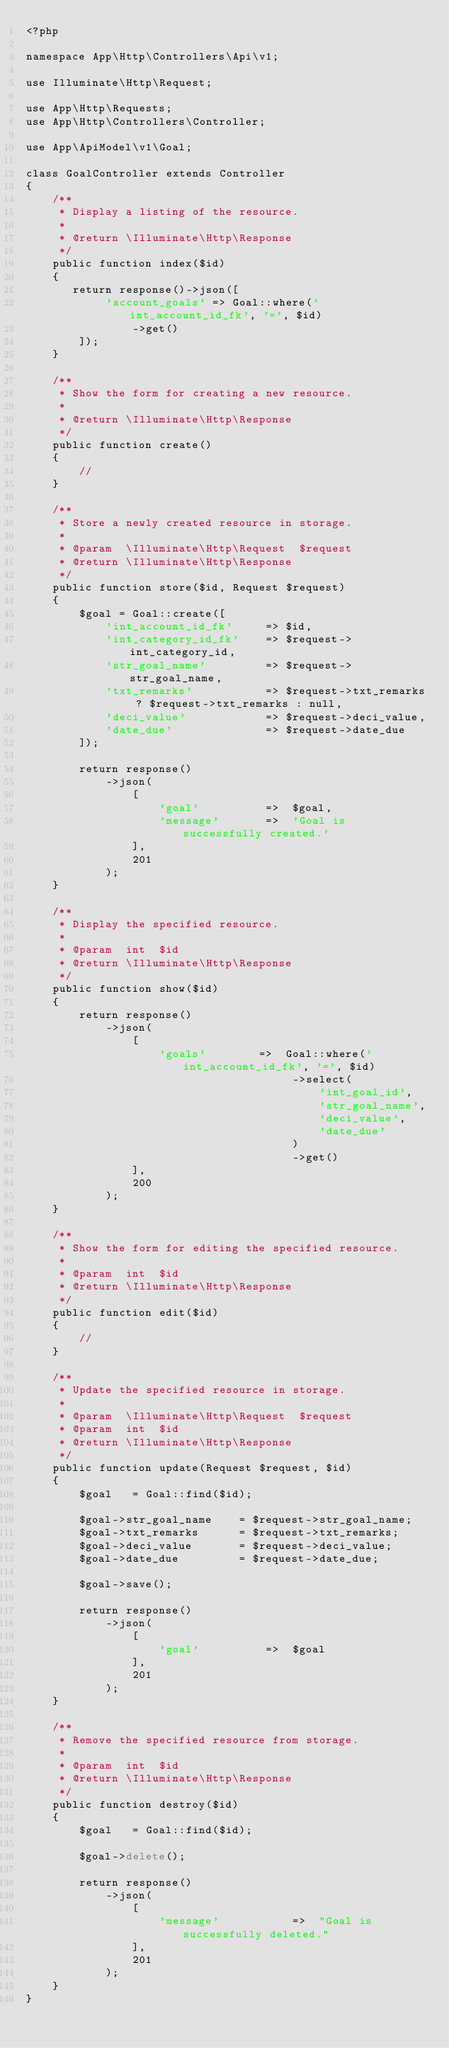Convert code to text. <code><loc_0><loc_0><loc_500><loc_500><_PHP_><?php

namespace App\Http\Controllers\Api\v1;

use Illuminate\Http\Request;

use App\Http\Requests;
use App\Http\Controllers\Controller;

use App\ApiModel\v1\Goal;

class GoalController extends Controller
{
    /**
     * Display a listing of the resource.
     *
     * @return \Illuminate\Http\Response
     */
    public function index($id)
    {
       return response()->json([
            'account_goals' => Goal::where('int_account_id_fk', '=', $id)
                ->get()
        ]);
    }

    /**
     * Show the form for creating a new resource.
     *
     * @return \Illuminate\Http\Response
     */
    public function create()
    {
        //
    }

    /**
     * Store a newly created resource in storage.
     *
     * @param  \Illuminate\Http\Request  $request
     * @return \Illuminate\Http\Response
     */
    public function store($id, Request $request)
    {
        $goal = Goal::create([
            'int_account_id_fk'     => $id,
            'int_category_id_fk'    => $request->int_category_id,
            'str_goal_name'         => $request->str_goal_name,
            'txt_remarks'           => $request->txt_remarks ? $request->txt_remarks : null,
            'deci_value'            => $request->deci_value,
            'date_due'              => $request->date_due
        ]);

        return response()
            ->json(
                [
                    'goal'          =>  $goal,
                    'message'       =>  'Goal is successfully created.'
                ],
                201
            );
    }

    /**
     * Display the specified resource.
     *
     * @param  int  $id
     * @return \Illuminate\Http\Response
     */
    public function show($id)
    {
        return response()
            ->json(
                [
                    'goals'        =>  Goal::where('int_account_id_fk', '=', $id)
                                        ->select(
                                            'int_goal_id',
                                            'str_goal_name',
                                            'deci_value',
                                            'date_due'
                                        )
                                        ->get()
                ],
                200
            );
    }

    /**
     * Show the form for editing the specified resource.
     *
     * @param  int  $id
     * @return \Illuminate\Http\Response
     */
    public function edit($id)
    {
        //
    }

    /**
     * Update the specified resource in storage.
     *
     * @param  \Illuminate\Http\Request  $request
     * @param  int  $id
     * @return \Illuminate\Http\Response
     */
    public function update(Request $request, $id)
    {
        $goal   = Goal::find($id);

        $goal->str_goal_name    = $request->str_goal_name;
        $goal->txt_remarks      = $request->txt_remarks;
        $goal->deci_value       = $request->deci_value;
        $goal->date_due         = $request->date_due;

        $goal->save();

        return response()
            ->json(
                [
                    'goal'          =>  $goal
                ],
                201
            );
    }

    /**
     * Remove the specified resource from storage.
     *
     * @param  int  $id
     * @return \Illuminate\Http\Response
     */
    public function destroy($id)
    {
        $goal   = Goal::find($id);

        $goal->delete();

        return response()
            ->json(
                [
                    'message'           =>  "Goal is successfully deleted."
                ],
                201
            );
    }
}
</code> 